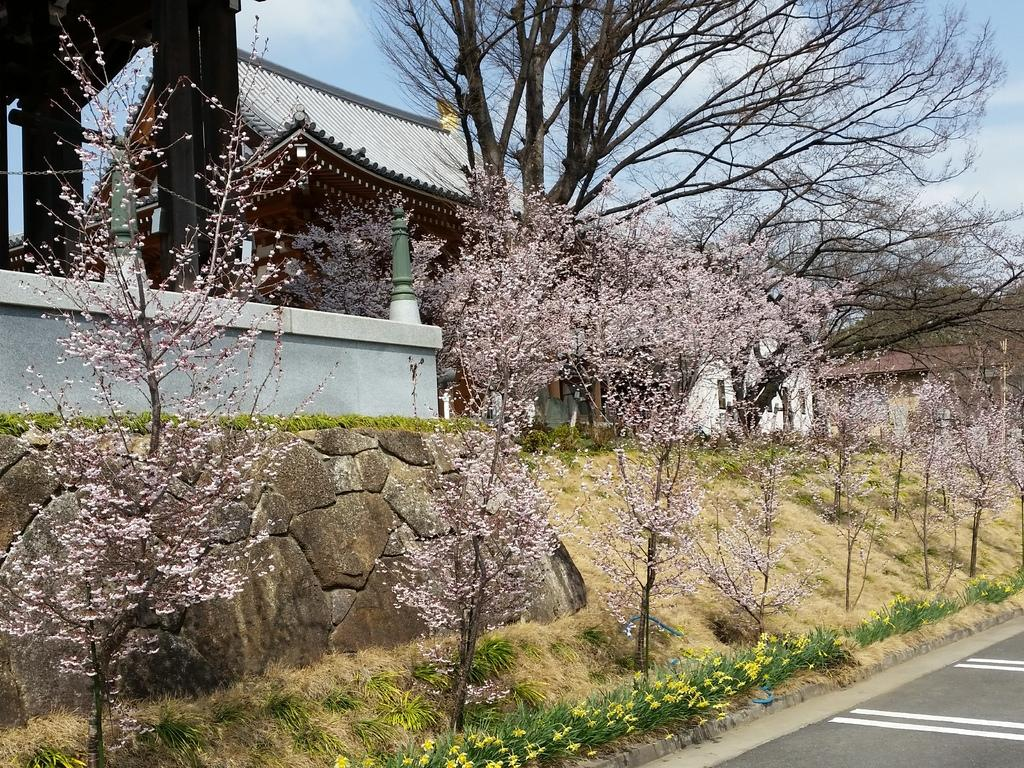What can be seen in the foreground of the image? In the foreground of the image, there is a road, flowers, grass, trees, and houses. What is visible at the top of the image? The sky is visible at the top of the image. Where is the chair located in the image? There is no chair present in the image. What type of trade is being conducted in the foreground of the image? There is no trade being conducted in the image; it features a road, flowers, grass, trees, and houses in the foreground. 